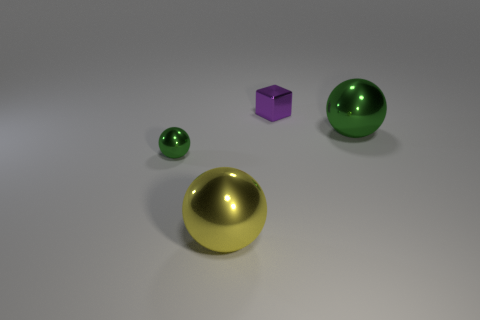Subtract 1 spheres. How many spheres are left? 2 Subtract all green balls. How many balls are left? 1 Add 3 large shiny balls. How many objects exist? 7 Subtract all balls. How many objects are left? 1 Subtract all blue cylinders. Subtract all large metallic balls. How many objects are left? 2 Add 4 spheres. How many spheres are left? 7 Add 1 yellow shiny objects. How many yellow shiny objects exist? 2 Subtract 0 purple balls. How many objects are left? 4 